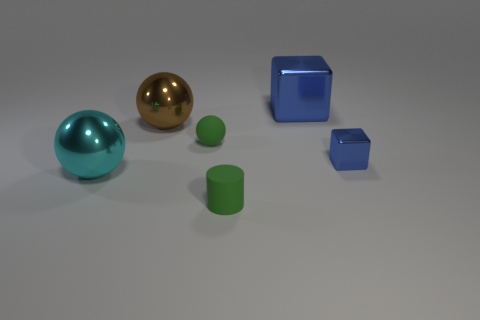The ball that is the same color as the rubber cylinder is what size?
Your answer should be compact. Small. What size is the brown object that is the same material as the large cyan thing?
Keep it short and to the point. Large. What number of other tiny objects have the same shape as the cyan object?
Offer a very short reply. 1. There is a small object that is in front of the large cyan shiny ball; does it have the same color as the tiny ball?
Ensure brevity in your answer.  Yes. There is a tiny object in front of the cyan metal thing behind the small cylinder; what number of cyan metallic spheres are behind it?
Ensure brevity in your answer.  1. How many objects are both behind the tiny green cylinder and to the right of the cyan metallic object?
Give a very brief answer. 4. The other object that is the same color as the small shiny object is what shape?
Give a very brief answer. Cube. Do the small green sphere and the cyan sphere have the same material?
Your answer should be very brief. No. There is a green thing behind the blue thing that is right of the large shiny object that is to the right of the small sphere; what shape is it?
Your answer should be very brief. Sphere. Is the number of small shiny blocks on the right side of the tiny blue metallic cube less than the number of large metallic things that are to the left of the green rubber cylinder?
Provide a short and direct response. Yes. 